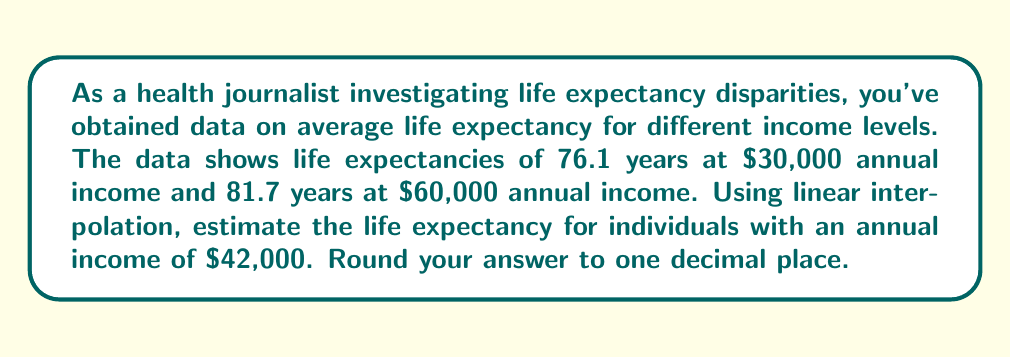Can you solve this math problem? To solve this problem, we'll use linear interpolation. The formula for linear interpolation is:

$$y = y_1 + \frac{(x - x_1)(y_2 - y_1)}{(x_2 - x_1)}$$

Where:
$x$ is the value we're interpolating for ($42,000)
$x_1$ is the lower known x-value ($30,000)
$x_2$ is the higher known x-value ($60,000)
$y_1$ is the y-value corresponding to $x_1$ (76.1 years)
$y_2$ is the y-value corresponding to $x_2$ (81.7 years)

Let's substitute these values into the formula:

$$y = 76.1 + \frac{(42,000 - 30,000)(81.7 - 76.1)}{(60,000 - 30,000)}$$

Simplify:
$$y = 76.1 + \frac{12,000 * 5.6}{30,000}$$

$$y = 76.1 + \frac{67,200}{30,000}$$

$$y = 76.1 + 2.24$$

$$y = 78.34$$

Rounding to one decimal place:
$$y \approx 78.3$$

Therefore, the estimated life expectancy for individuals with an annual income of $42,000 is 78.3 years.
Answer: 78.3 years 